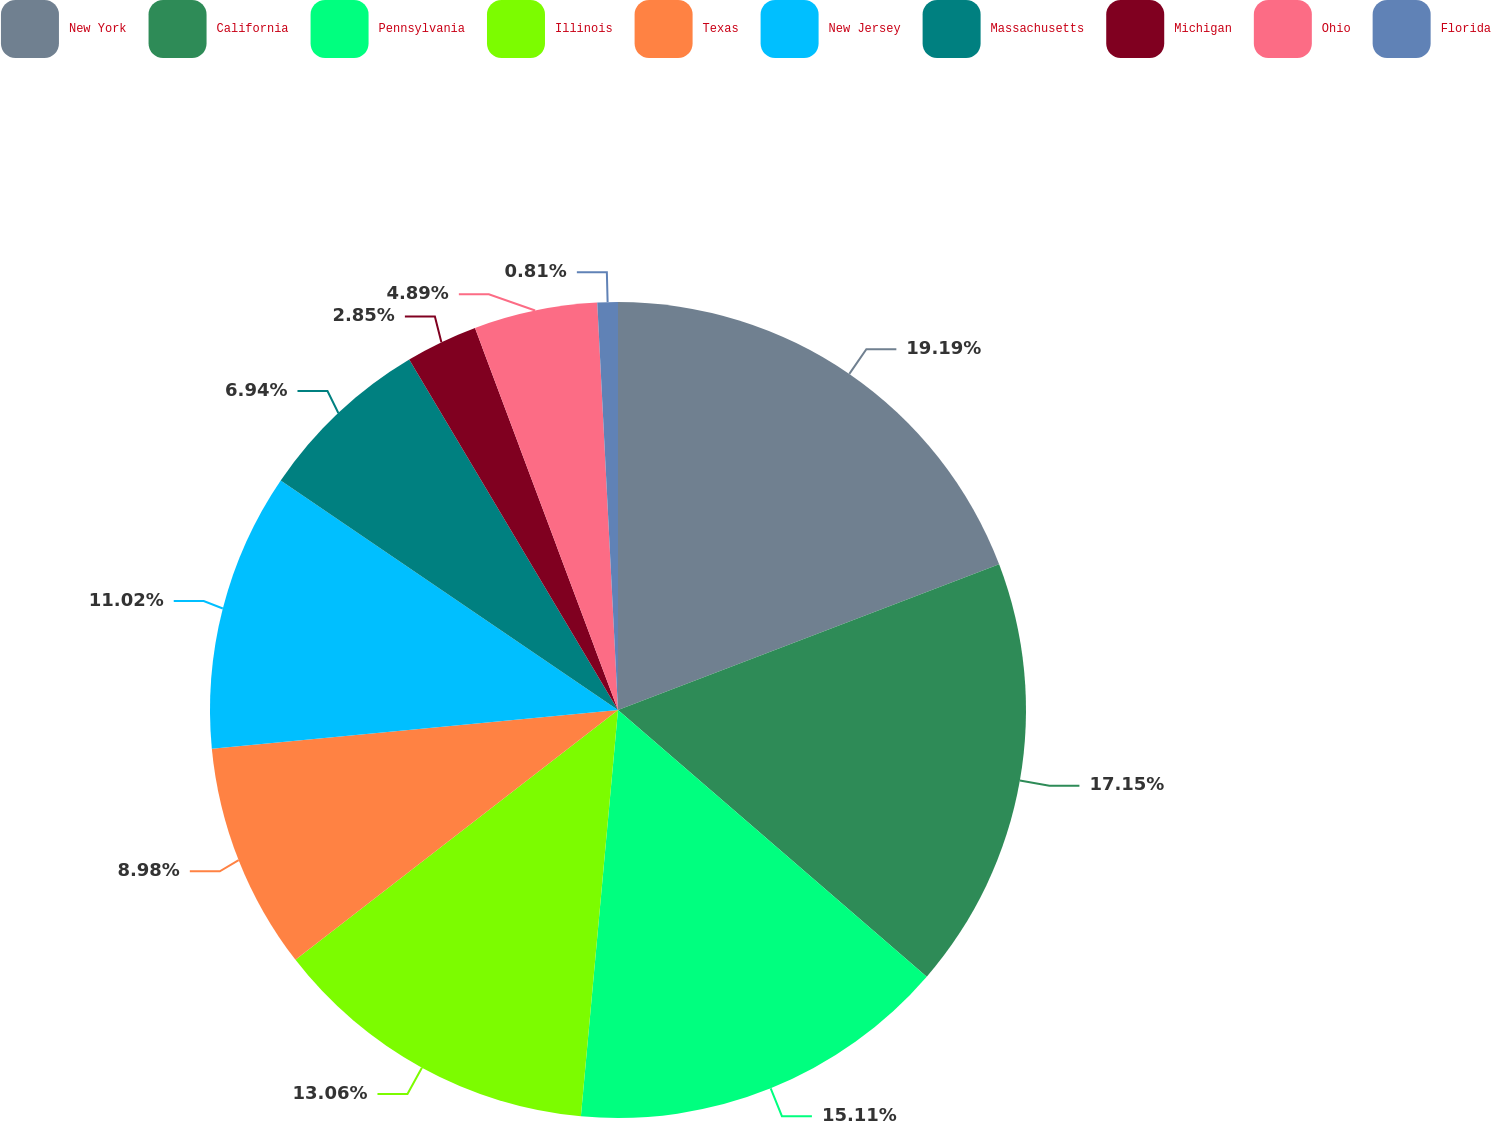<chart> <loc_0><loc_0><loc_500><loc_500><pie_chart><fcel>New York<fcel>California<fcel>Pennsylvania<fcel>Illinois<fcel>Texas<fcel>New Jersey<fcel>Massachusetts<fcel>Michigan<fcel>Ohio<fcel>Florida<nl><fcel>19.19%<fcel>17.15%<fcel>15.11%<fcel>13.06%<fcel>8.98%<fcel>11.02%<fcel>6.94%<fcel>2.85%<fcel>4.89%<fcel>0.81%<nl></chart> 